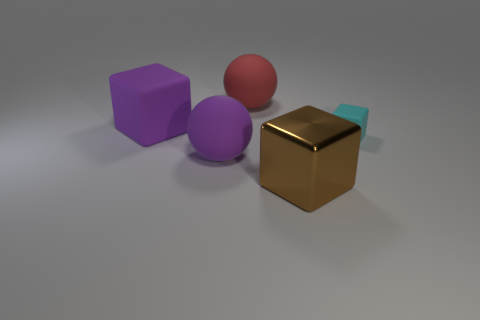Subtract all large brown shiny cubes. How many cubes are left? 2 Add 2 cyan rubber cubes. How many objects exist? 7 Subtract all blocks. How many objects are left? 2 Add 1 big brown metal blocks. How many big brown metal blocks are left? 2 Add 3 big matte spheres. How many big matte spheres exist? 5 Subtract 0 red cubes. How many objects are left? 5 Subtract all yellow blocks. Subtract all gray spheres. How many blocks are left? 3 Subtract all large gray rubber balls. Subtract all big purple spheres. How many objects are left? 4 